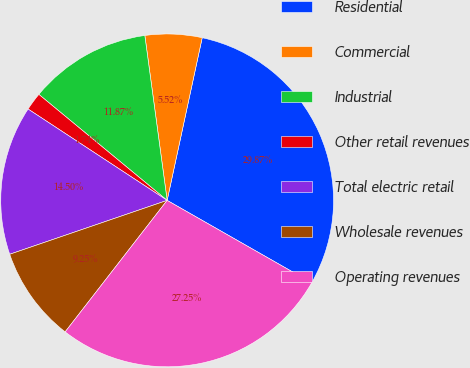<chart> <loc_0><loc_0><loc_500><loc_500><pie_chart><fcel>Residential<fcel>Commercial<fcel>Industrial<fcel>Other retail revenues<fcel>Total electric retail<fcel>Wholesale revenues<fcel>Operating revenues<nl><fcel>29.87%<fcel>5.52%<fcel>11.87%<fcel>1.74%<fcel>14.5%<fcel>9.25%<fcel>27.25%<nl></chart> 